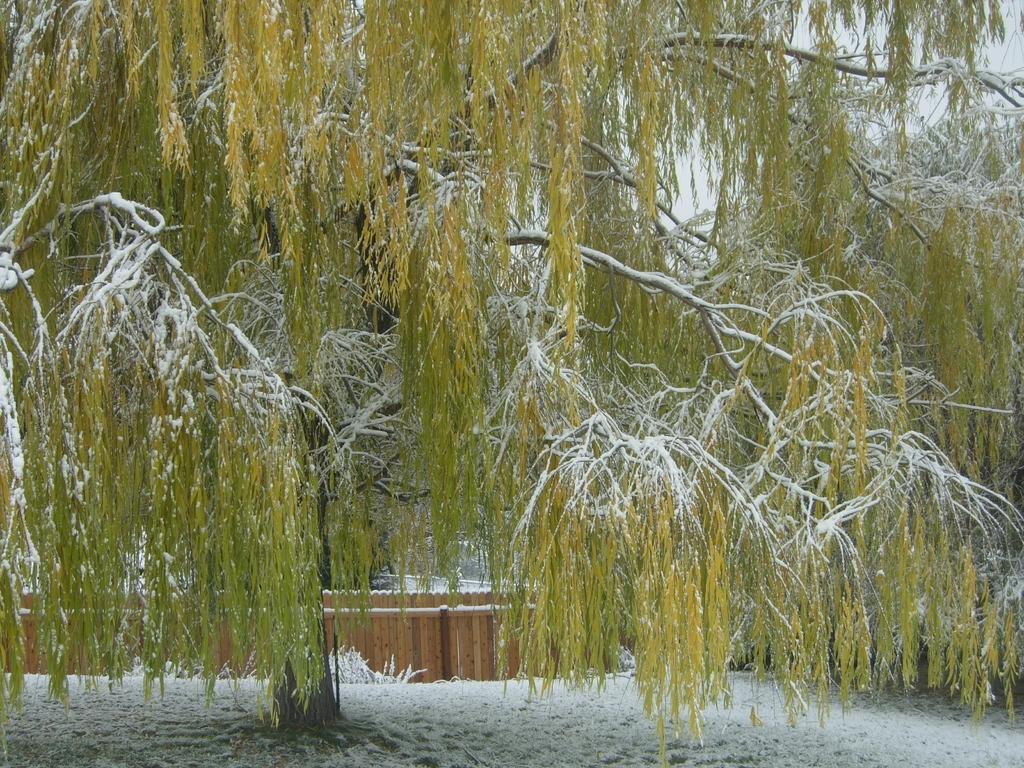How would you summarize this image in a sentence or two? In this picture, there is a tree covered with snow. At the bottom, there is snow. 